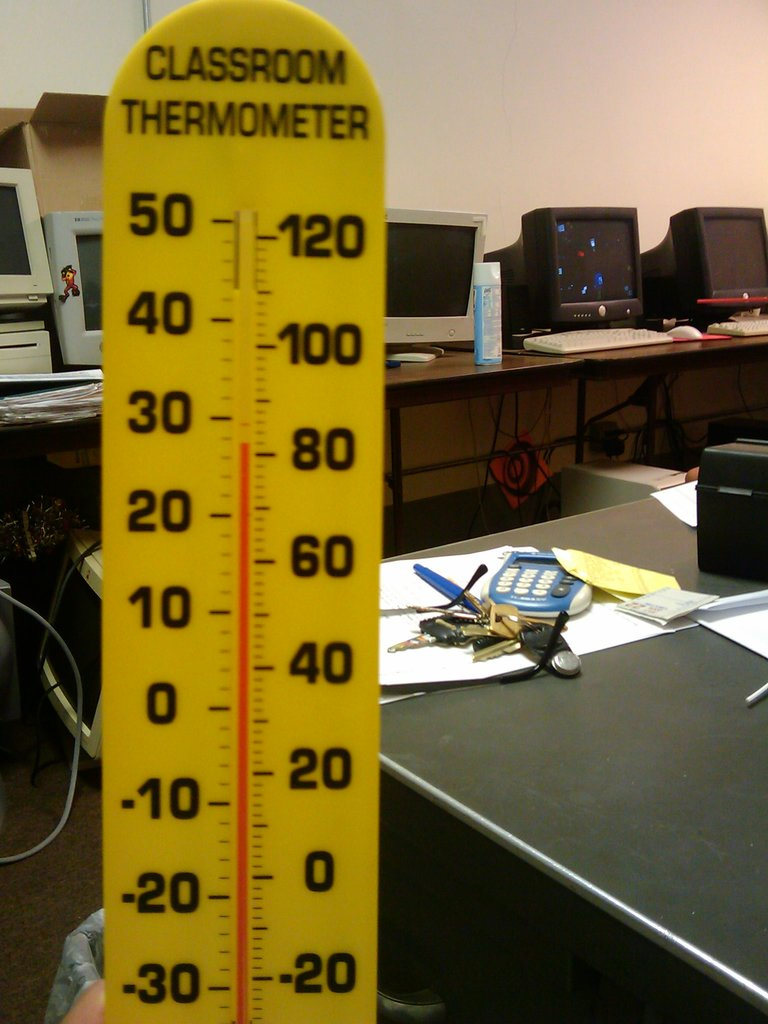What do you see happening in this image? The image features a large classroom thermometer prominently placed in the foreground, with a scale from -30 to 50 degrees Celsius. The thermometer is labeled clearly at the top, which suggests its use in an educational setting for teaching students about temperature measurement. In the blurry background, we see a desk teeming with a scattering of items, such as a calculator, several sets of keys, papers, and behind them, computer monitors. This clutter may indicate a busy working or learning environment, one that possibly involves scientific or mathematical activities, given the presence of a calculator. 